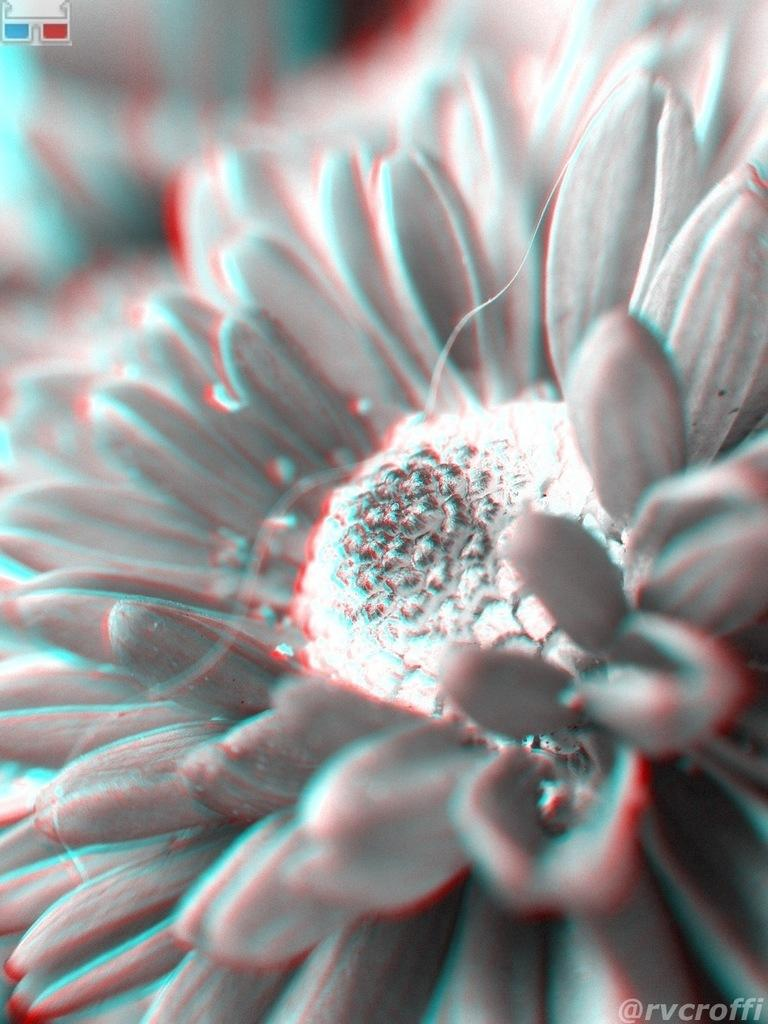What type of image is being described? The image is an edited picture. What can be seen in the edited picture? There is a flower in the image. What is the level of noise in the image? The image is a still picture and does not have a noise level. --- 